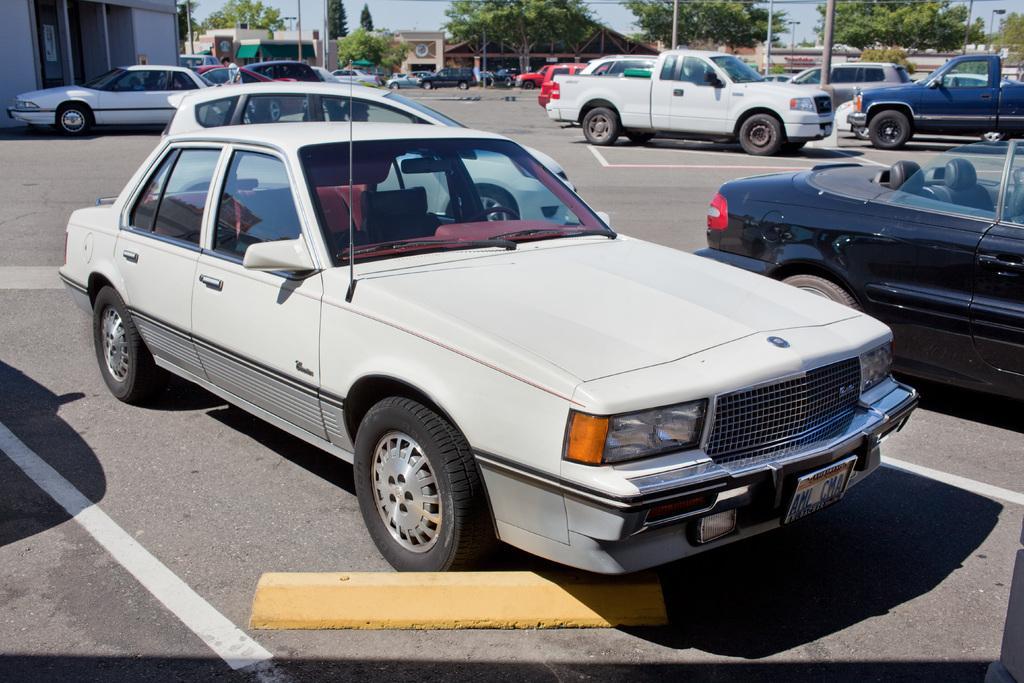Could you give a brief overview of what you see in this image? It is a car in white color parked on the road and beside it there are few other vehicles that are parked on the road. These are the green color trees. 